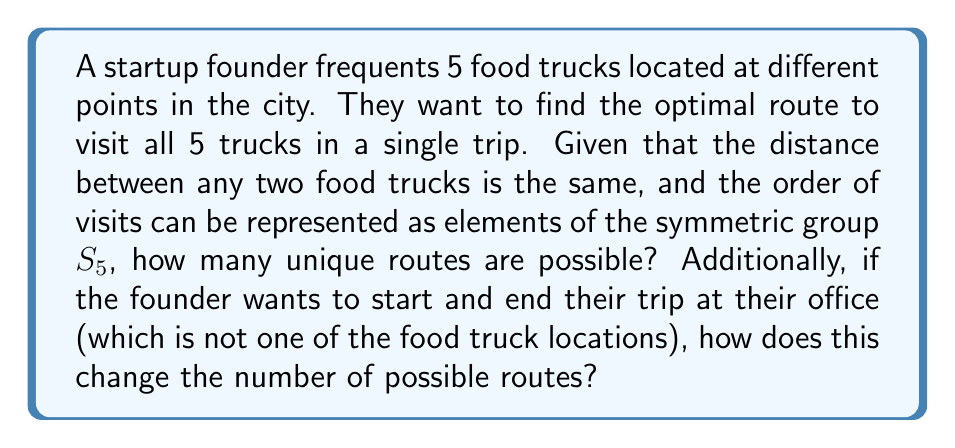Give your solution to this math problem. Let's approach this problem step by step:

1) First, we need to understand what the question is asking. We're dealing with permutations of 5 food trucks, which can be represented by elements of the symmetric group $S_5$.

2) In the first part of the question, we're asked to find the number of unique routes to visit all 5 trucks. This is equivalent to finding the order of $S_5$.

3) The order of $S_5$ is given by $5!$ (5 factorial), which can be calculated as:

   $$|S_5| = 5! = 5 \times 4 \times 3 \times 2 \times 1 = 120$$

4) Therefore, there are 120 unique routes to visit all 5 food trucks.

5) For the second part of the question, we need to consider that the founder starts and ends at their office. This changes our problem slightly.

6) Now, we're dealing with a cycle that starts and ends at the office, with the 5 food trucks in between. This is equivalent to finding the number of cyclic permutations of 5 elements.

7) The number of cyclic permutations of $n$ elements is $(n-1)!$. In this case, $n = 5$.

8) So, the number of unique routes starting and ending at the office is:

   $$(5-1)! = 4! = 4 \times 3 \times 2 \times 1 = 24$$

Therefore, when the founder starts and ends at their office, there are 24 unique routes to visit all 5 food trucks.
Answer: There are 120 unique routes to visit all 5 food trucks when starting at any truck. When starting and ending at the office, there are 24 unique routes. 